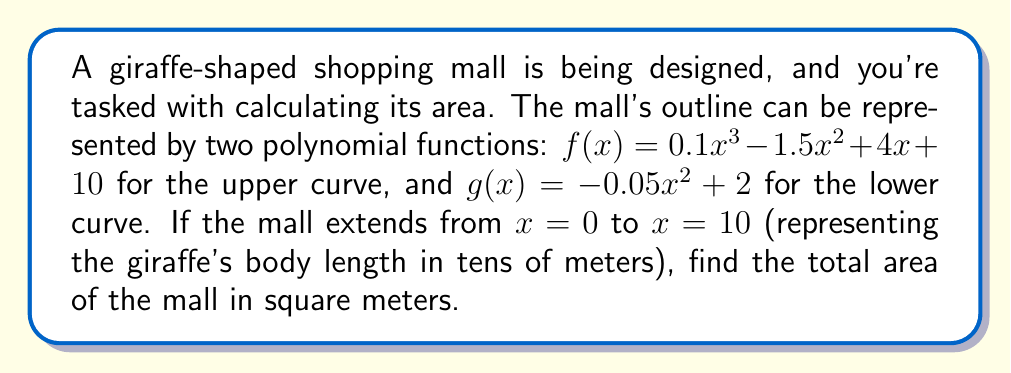Can you solve this math problem? To find the area between two curves, we need to integrate the difference of the functions over the given interval. Here's how we solve this step-by-step:

1) The area is given by the definite integral:
   $$A = \int_0^{10} [f(x) - g(x)] dx$$

2) Substitute the functions:
   $$A = \int_0^{10} [(0.1x^3 - 1.5x^2 + 4x + 10) - (-0.05x^2 + 2)] dx$$

3) Simplify:
   $$A = \int_0^{10} (0.1x^3 - 1.45x^2 + 4x + 8) dx$$

4) Integrate:
   $$A = [\frac{0.1x^4}{4} - \frac{1.45x^3}{3} + 2x^2 + 8x]_0^{10}$$

5) Evaluate at the limits:
   $$A = (\frac{0.1(10^4)}{4} - \frac{1.45(10^3)}{3} + 2(10^2) + 8(10)) - (0 - 0 + 0 + 0)$$

6) Calculate:
   $$A = (250 - 483.33 + 200 + 80) - 0 = 46.67$$

7) Since x was in tens of meters, we need to multiply by 100 to get square meters:
   $$A = 46.67 * 100 = 4,667 \text{ m}^2$$
Answer: 4,667 m² 